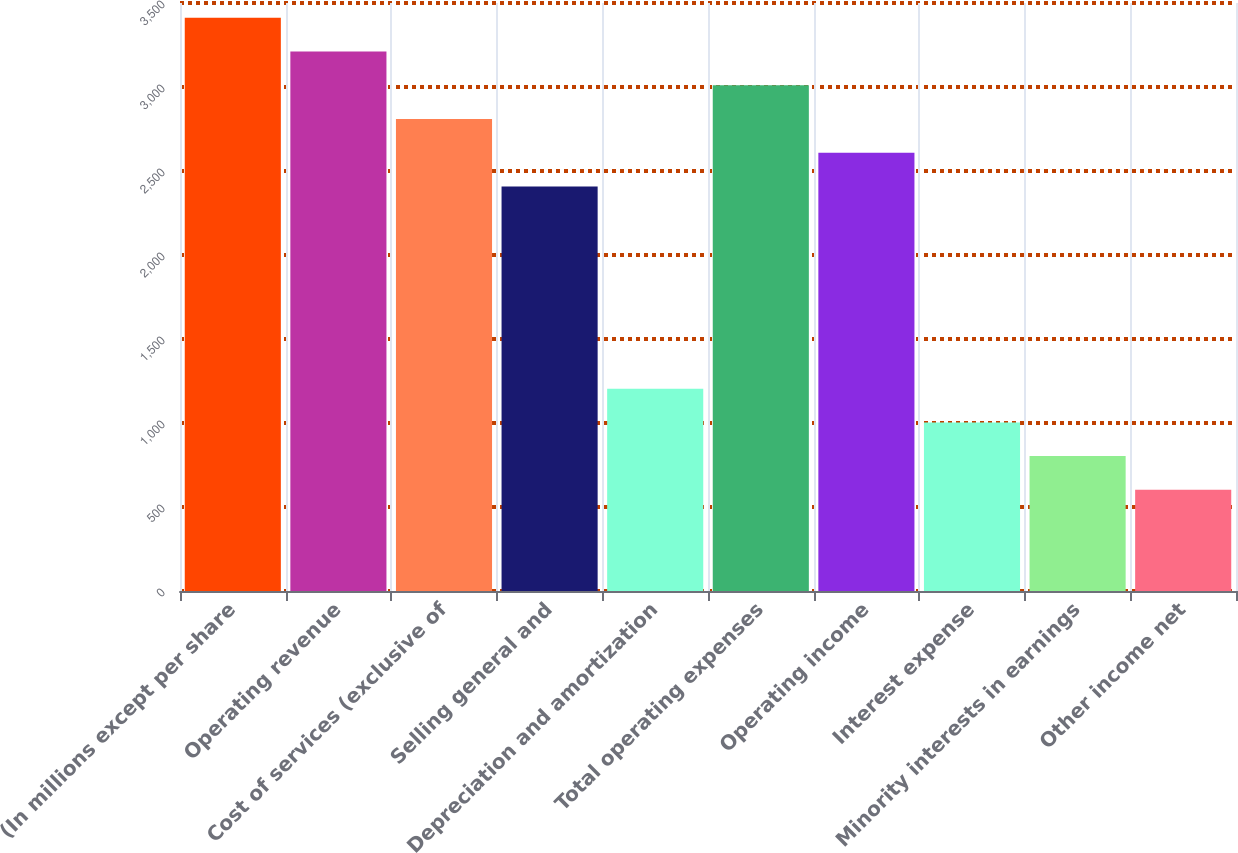<chart> <loc_0><loc_0><loc_500><loc_500><bar_chart><fcel>(In millions except per share<fcel>Operating revenue<fcel>Cost of services (exclusive of<fcel>Selling general and<fcel>Depreciation and amortization<fcel>Total operating expenses<fcel>Operating income<fcel>Interest expense<fcel>Minority interests in earnings<fcel>Other income net<nl><fcel>3411.72<fcel>3211.04<fcel>2809.68<fcel>2408.32<fcel>1204.24<fcel>3010.36<fcel>2609<fcel>1003.56<fcel>802.88<fcel>602.2<nl></chart> 